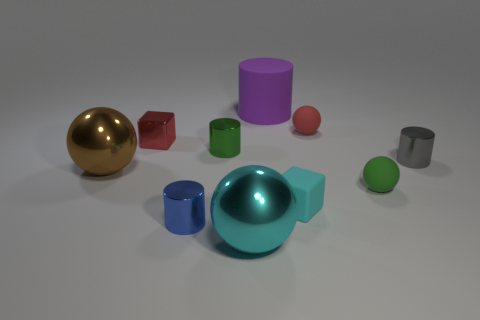There is a tiny green object left of the green rubber object; does it have the same shape as the big cyan shiny thing?
Ensure brevity in your answer.  No. Is the number of small gray objects less than the number of big gray metallic blocks?
Make the answer very short. No. There is a purple object that is the same size as the brown sphere; what is its material?
Ensure brevity in your answer.  Rubber. Is the color of the matte block the same as the large object in front of the large brown ball?
Offer a very short reply. Yes. Are there fewer red objects that are on the left side of the blue metal cylinder than red things?
Your response must be concise. Yes. What number of big spheres are there?
Provide a succinct answer. 2. What is the shape of the large metal object to the left of the cyan shiny object that is right of the green metallic thing?
Provide a succinct answer. Sphere. What number of small matte spheres are right of the gray metal cylinder?
Keep it short and to the point. 0. Is the blue object made of the same material as the tiny cube to the right of the large cyan metal thing?
Ensure brevity in your answer.  No. Is there a green metal thing of the same size as the brown metal ball?
Keep it short and to the point. No. 